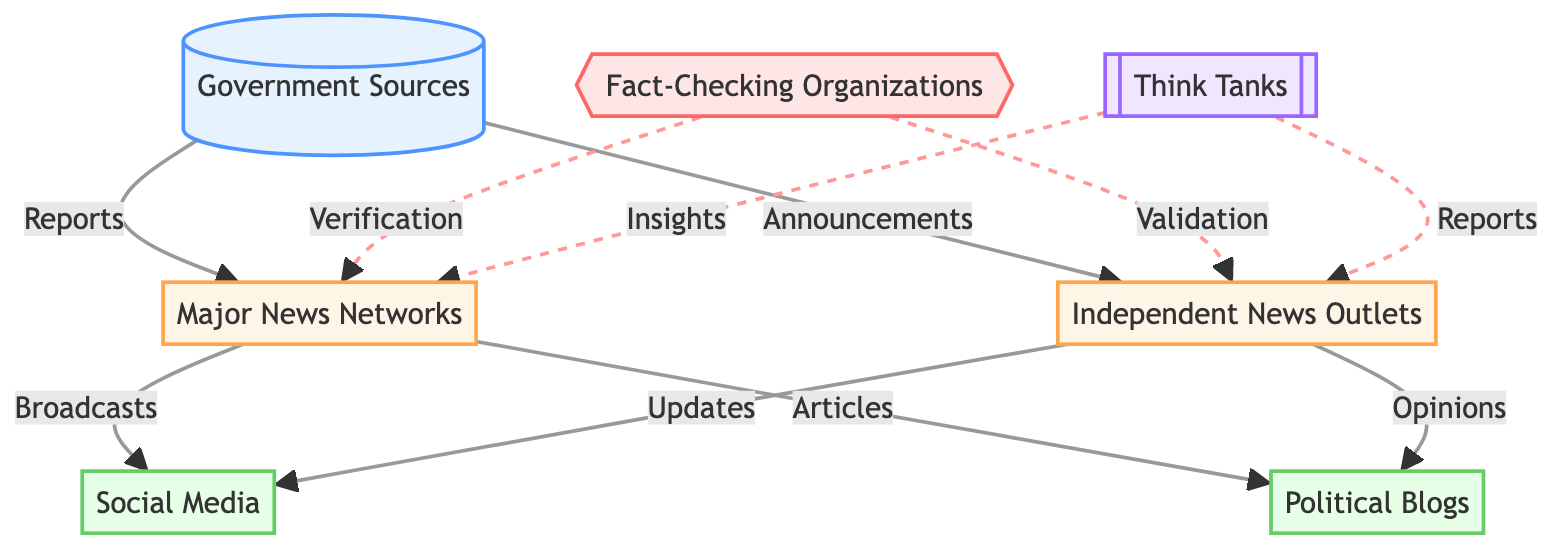What are the major news networks connected to? The major news networks receive reports from government sources and distribute broadcasts to social media, as well as articles to political blogs. Thus, the connections show that they act as a key link between government sources and public platforms.
Answer: Social Media, Political Blogs How many nodes are in this diagram? To determine the total number of nodes, we count all distinct elements present in the diagram. The nodes are: Government Sources, Major News Networks, Independent News Outlets, Social Media, Political Blogs, Fact-Checking Organizations, and Think Tanks, totaling 7.
Answer: 7 Which node does not have direct incoming connections? By reviewing the flow, the only node that does not receive any data or reports from another node is Political Blogs, which only receives information from Major News Networks and Independent News Outlets. Thus, this node stands out as having no incoming relationships.
Answer: Political Blogs What role does the Fact-Checking Organizations node play? The Fact-Checking Organizations are primarily involved in verification, indicated by the dashed lines connecting them to Major News Networks and Independent News Outlets, signifying they validate and verify information.
Answer: Verification Which type of organization provides insights to Major News Networks? The Think Tanks provide insights to the Major News Networks, as indicated by the dashed line flowing from the Think Tanks node to this distribution node, which portrays their analytical role.
Answer: Think Tanks How many edges connect the Government Sources to other nodes? Counting the arrows pointing away from the Government Sources node indicates it connects to 2 edges: one to Major News Networks and another to Independent News Outlets, showing its influence spreads between these distributions.
Answer: 2 What is the relationship between Independent News Outlets and Social Media? Independent News Outlets provide updates to Social Media, as shown by the direct link originating from Independent News Outlets and connecting towards Social Media, which suggests a flow of information.
Answer: Updates What is the verification process in the diagram? The verification process involves the Fact-Checking Organizations, which validate reports and articles from both Major News Networks and Independent News Outlets, helping to ensure the accuracy of distributed information.
Answer: Validation How do Think Tanks interact with the other nodes? Think Tanks provide insights and reports to Major News Networks and Independent News Outlets, respectively, showing their dual role in informing both forms of news distribution, enriching their content.
Answer: Insights, Reports 